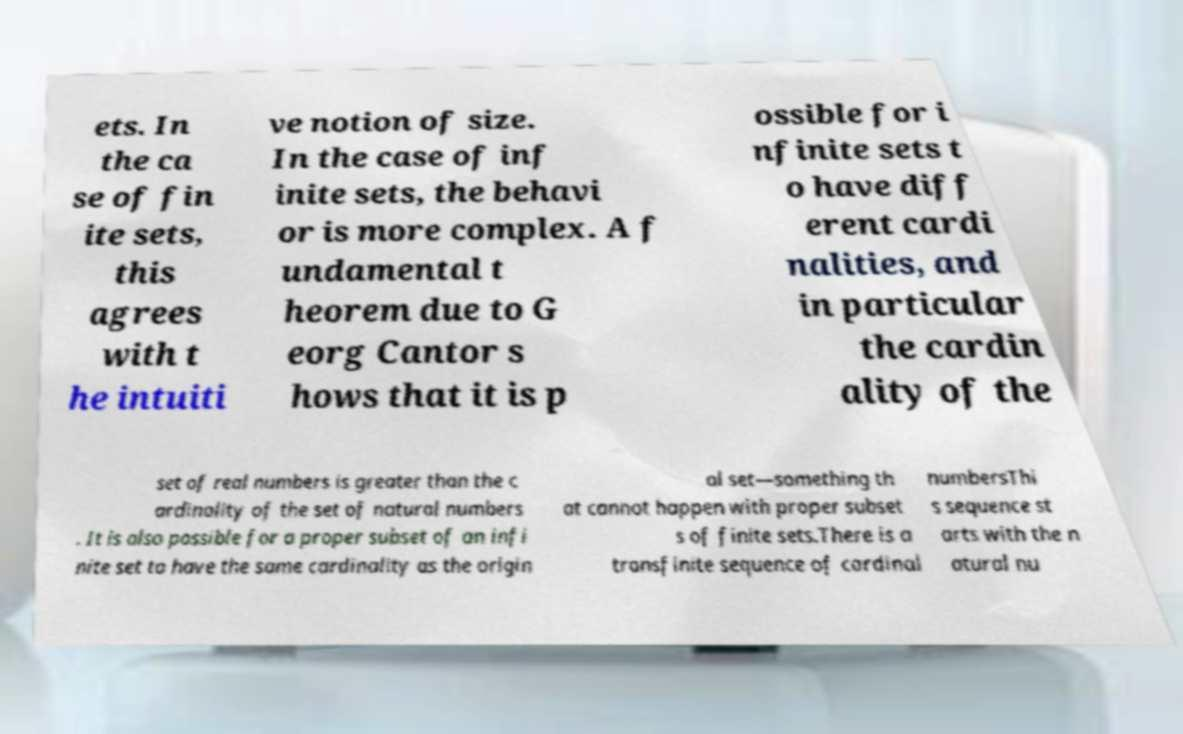There's text embedded in this image that I need extracted. Can you transcribe it verbatim? ets. In the ca se of fin ite sets, this agrees with t he intuiti ve notion of size. In the case of inf inite sets, the behavi or is more complex. A f undamental t heorem due to G eorg Cantor s hows that it is p ossible for i nfinite sets t o have diff erent cardi nalities, and in particular the cardin ality of the set of real numbers is greater than the c ardinality of the set of natural numbers . It is also possible for a proper subset of an infi nite set to have the same cardinality as the origin al set—something th at cannot happen with proper subset s of finite sets.There is a transfinite sequence of cardinal numbersThi s sequence st arts with the n atural nu 